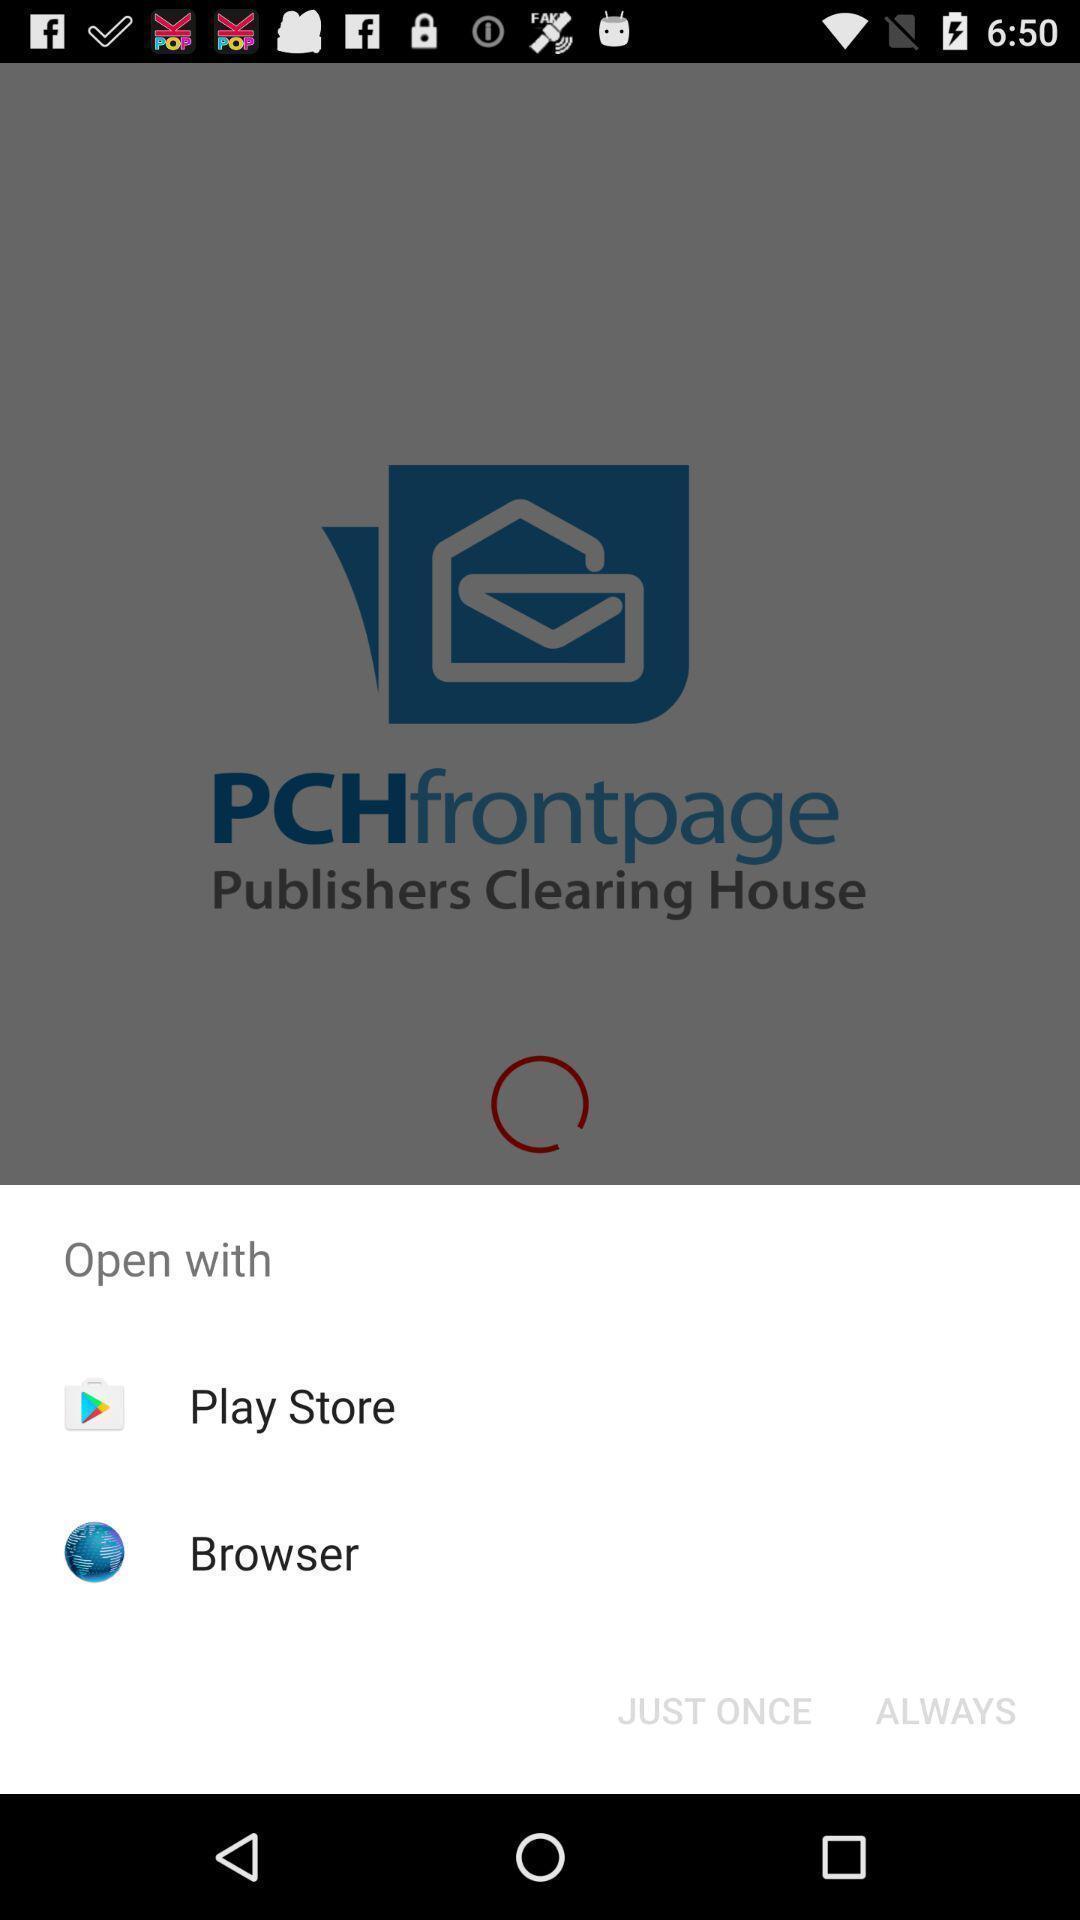Please provide a description for this image. Popup showing different apps to select. 